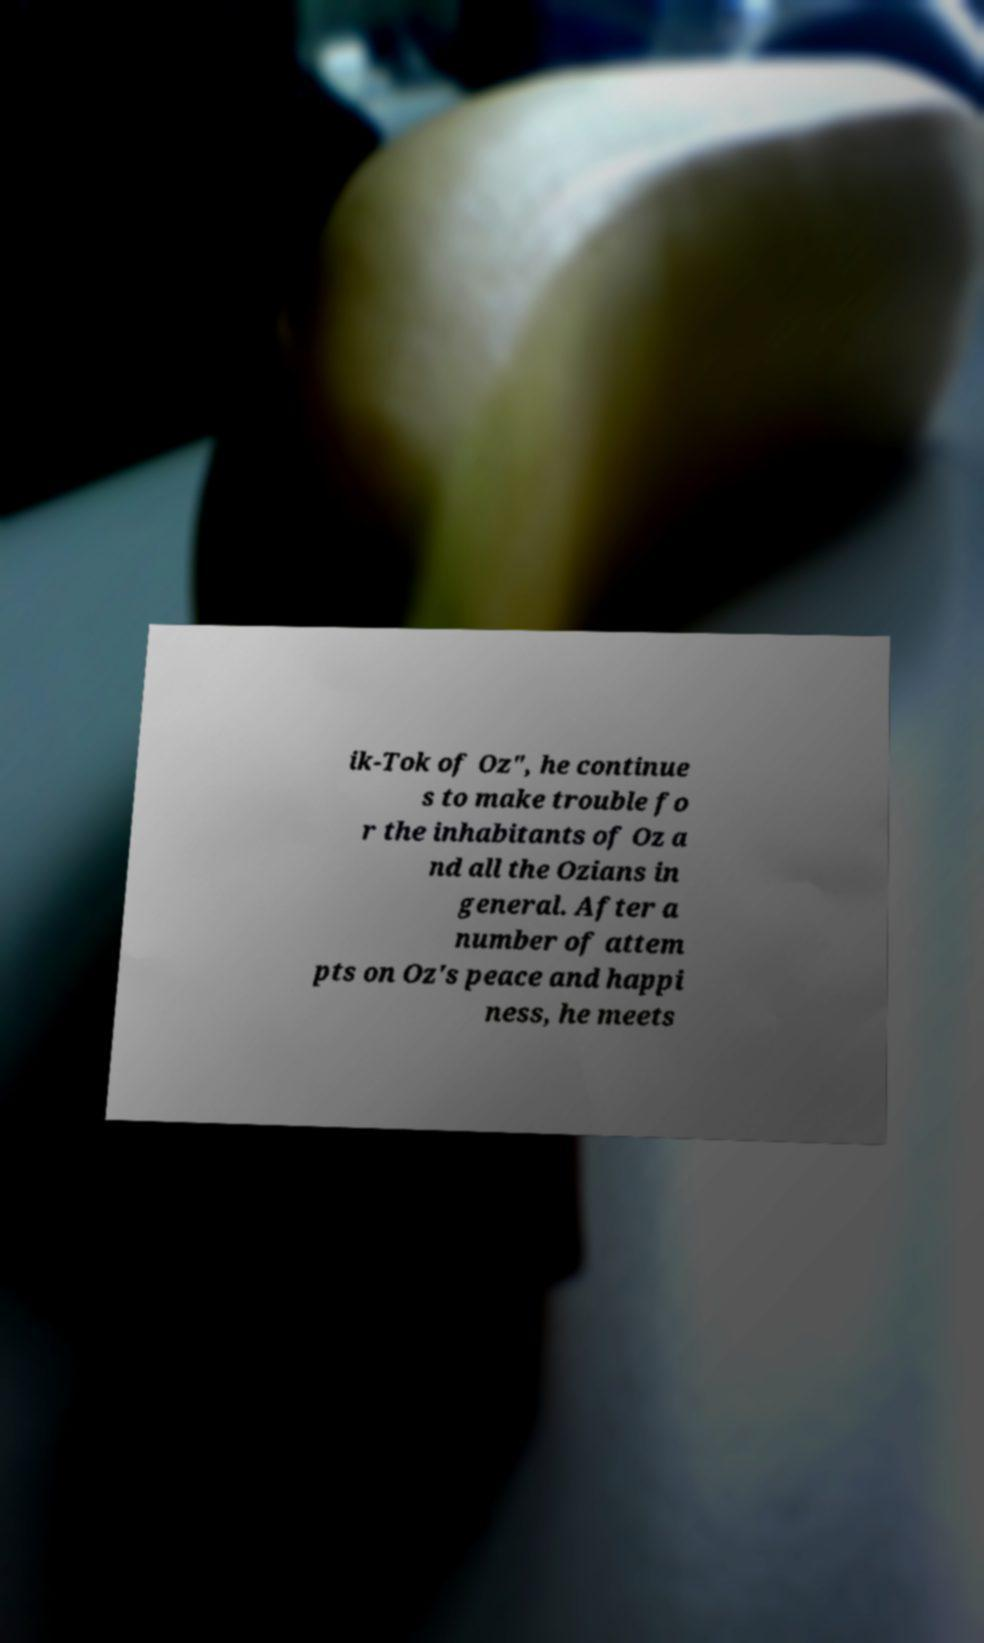I need the written content from this picture converted into text. Can you do that? ik-Tok of Oz", he continue s to make trouble fo r the inhabitants of Oz a nd all the Ozians in general. After a number of attem pts on Oz's peace and happi ness, he meets 